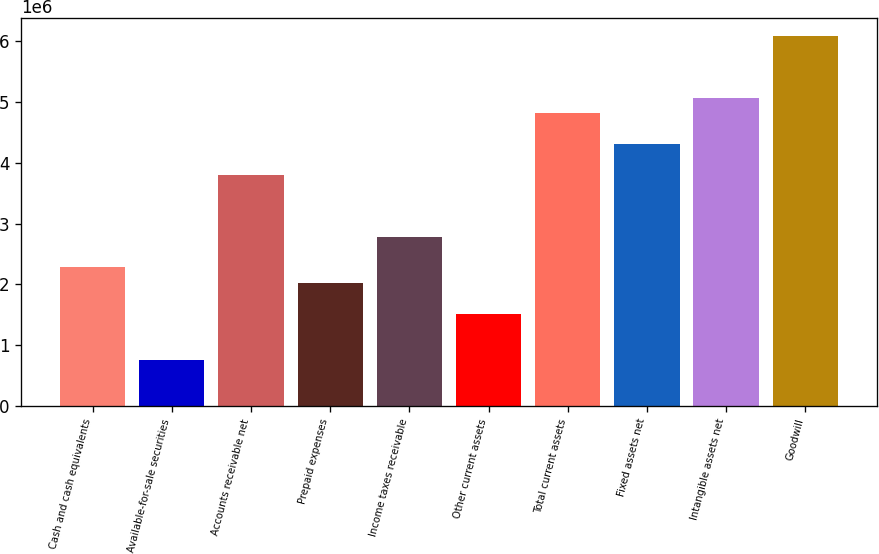Convert chart to OTSL. <chart><loc_0><loc_0><loc_500><loc_500><bar_chart><fcel>Cash and cash equivalents<fcel>Available-for-sale securities<fcel>Accounts receivable net<fcel>Prepaid expenses<fcel>Income taxes receivable<fcel>Other current assets<fcel>Total current assets<fcel>Fixed assets net<fcel>Intangible assets net<fcel>Goodwill<nl><fcel>2.2804e+06<fcel>760225<fcel>3.80058e+06<fcel>2.02704e+06<fcel>2.78713e+06<fcel>1.52031e+06<fcel>4.81403e+06<fcel>4.3073e+06<fcel>5.06739e+06<fcel>6.08084e+06<nl></chart> 